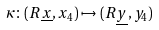Convert formula to latex. <formula><loc_0><loc_0><loc_500><loc_500>\kappa \colon ( R \underline { x } , x _ { 4 } ) \mapsto ( R \underline { y } , y _ { 4 } )</formula> 